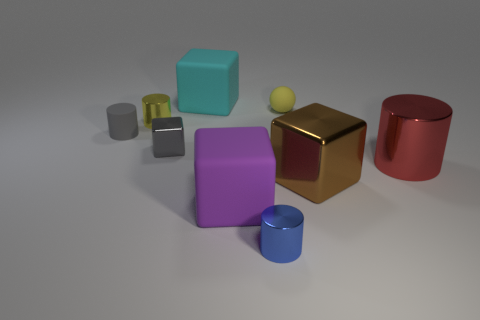Subtract all large red metal cylinders. How many cylinders are left? 3 Subtract all blue cylinders. How many cylinders are left? 3 Subtract all blue cubes. Subtract all gray cylinders. How many cubes are left? 4 Subtract all cylinders. How many objects are left? 5 Add 6 tiny blocks. How many tiny blocks exist? 7 Subtract 1 yellow spheres. How many objects are left? 8 Subtract all tiny yellow shiny cylinders. Subtract all small blue metallic cylinders. How many objects are left? 7 Add 4 rubber spheres. How many rubber spheres are left? 5 